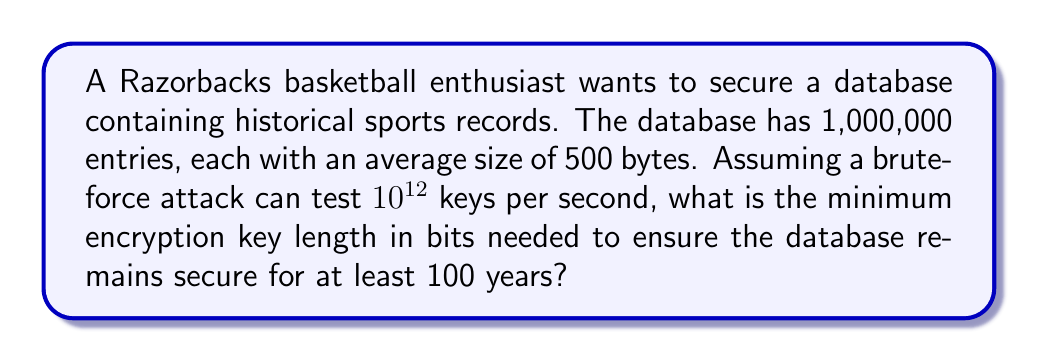Give your solution to this math problem. To determine the required key length, we'll follow these steps:

1. Calculate the total size of the database:
   $1,000,000 \text{ entries} \times 500 \text{ bytes/entry} = 5 \times 10^8 \text{ bytes}$

2. Convert 100 years to seconds:
   $100 \text{ years} \times 365 \text{ days/year} \times 24 \text{ hours/day} \times 3600 \text{ seconds/hour} = 3,153,600,000 \text{ seconds}$

3. Calculate the total number of keys that can be tested in 100 years:
   $3,153,600,000 \text{ seconds} \times 10^{12} \text{ keys/second} = 3.1536 \times 10^{21} \text{ keys}$

4. Find the minimum number of bits needed to represent this many keys:
   $2^n > 3.1536 \times 10^{21}$, where $n$ is the number of bits

5. Solve for $n$ using logarithms:
   $n > \log_2(3.1536 \times 10^{21})$
   $n > 71.12$

6. Round up to the nearest whole number:
   $n = 72 \text{ bits}$

Therefore, a 72-bit encryption key would be the minimum length needed to secure the database for at least 100 years against a brute-force attack.

However, in practice, we typically use standard key lengths that are powers of 2. The next standard key length above 72 bits is 128 bits, which is commonly used in symmetric encryption algorithms like AES.
Answer: 128 bits 